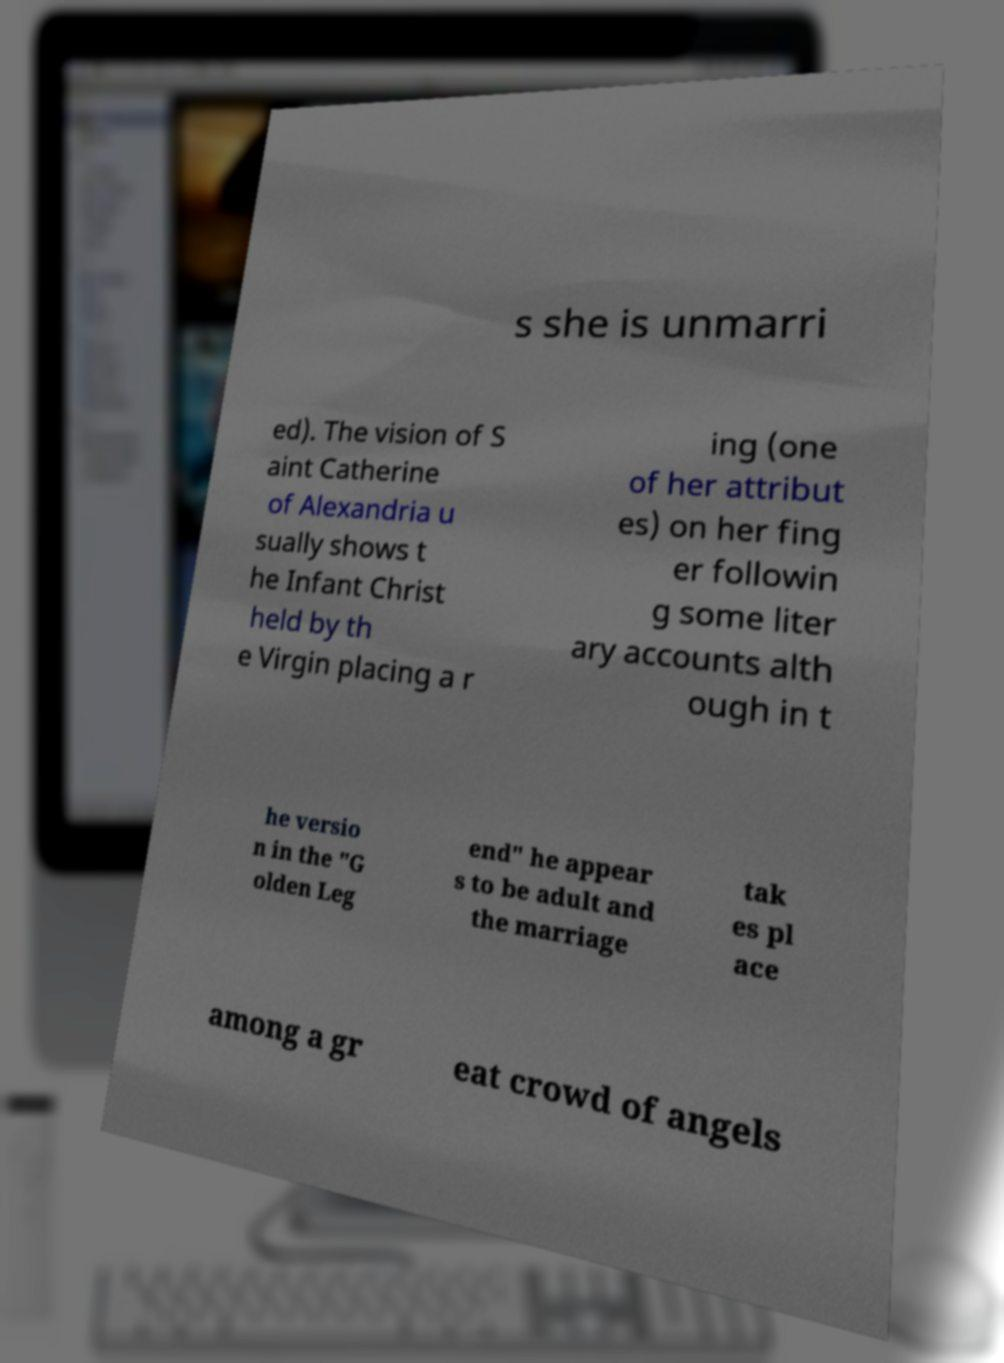Could you extract and type out the text from this image? s she is unmarri ed). The vision of S aint Catherine of Alexandria u sually shows t he Infant Christ held by th e Virgin placing a r ing (one of her attribut es) on her fing er followin g some liter ary accounts alth ough in t he versio n in the "G olden Leg end" he appear s to be adult and the marriage tak es pl ace among a gr eat crowd of angels 